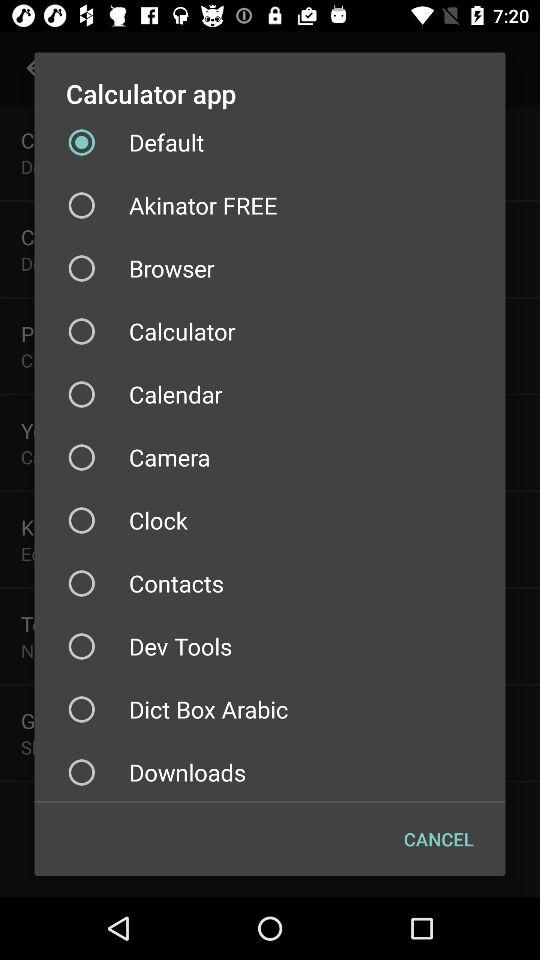What option is selected in the "Calculator" app? The selected option is "Default". 